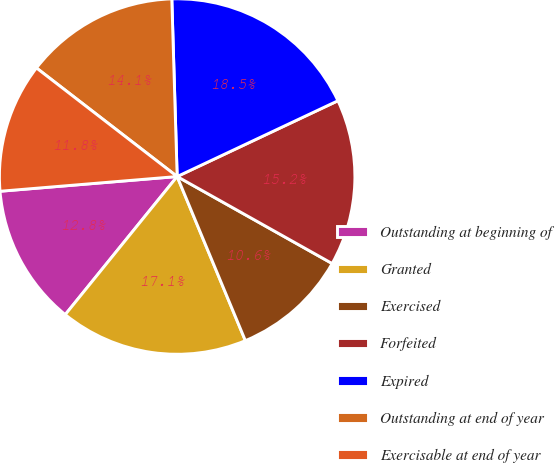Convert chart. <chart><loc_0><loc_0><loc_500><loc_500><pie_chart><fcel>Outstanding at beginning of<fcel>Granted<fcel>Exercised<fcel>Forfeited<fcel>Expired<fcel>Outstanding at end of year<fcel>Exercisable at end of year<nl><fcel>12.84%<fcel>17.11%<fcel>10.59%<fcel>15.15%<fcel>18.47%<fcel>14.06%<fcel>11.78%<nl></chart> 